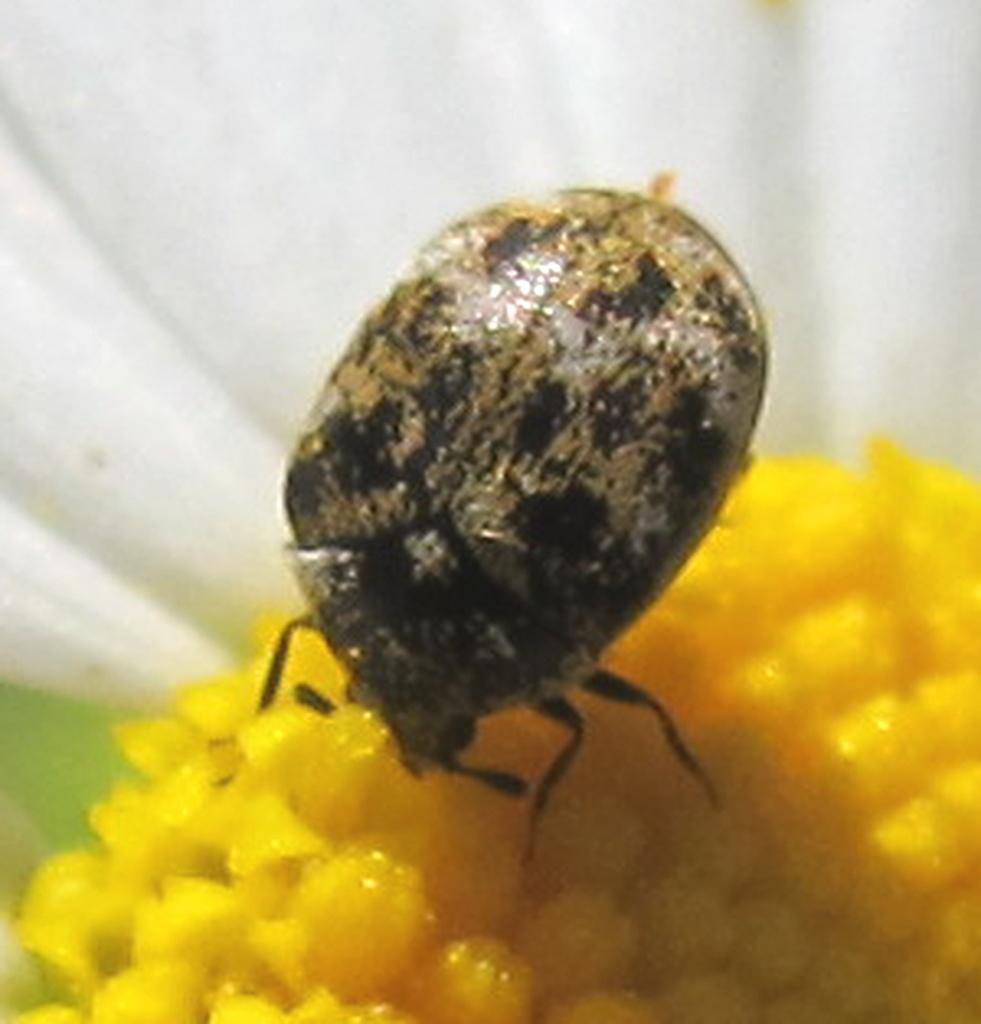Please provide a concise description of this image. This looks like a leaf beetle on the flower. This flower is yellow in color. The background looks white in color. 